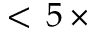Convert formula to latex. <formula><loc_0><loc_0><loc_500><loc_500>< \, 5 \, \times</formula> 